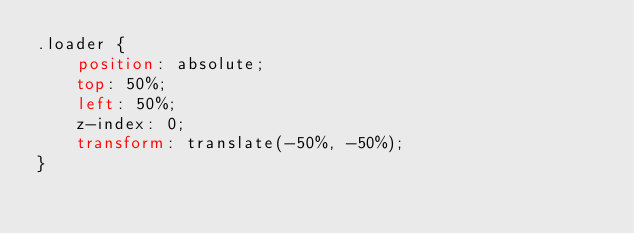<code> <loc_0><loc_0><loc_500><loc_500><_CSS_>.loader {
    position: absolute;
    top: 50%;
    left: 50%;
    z-index: 0;
    transform: translate(-50%, -50%);
}
</code> 